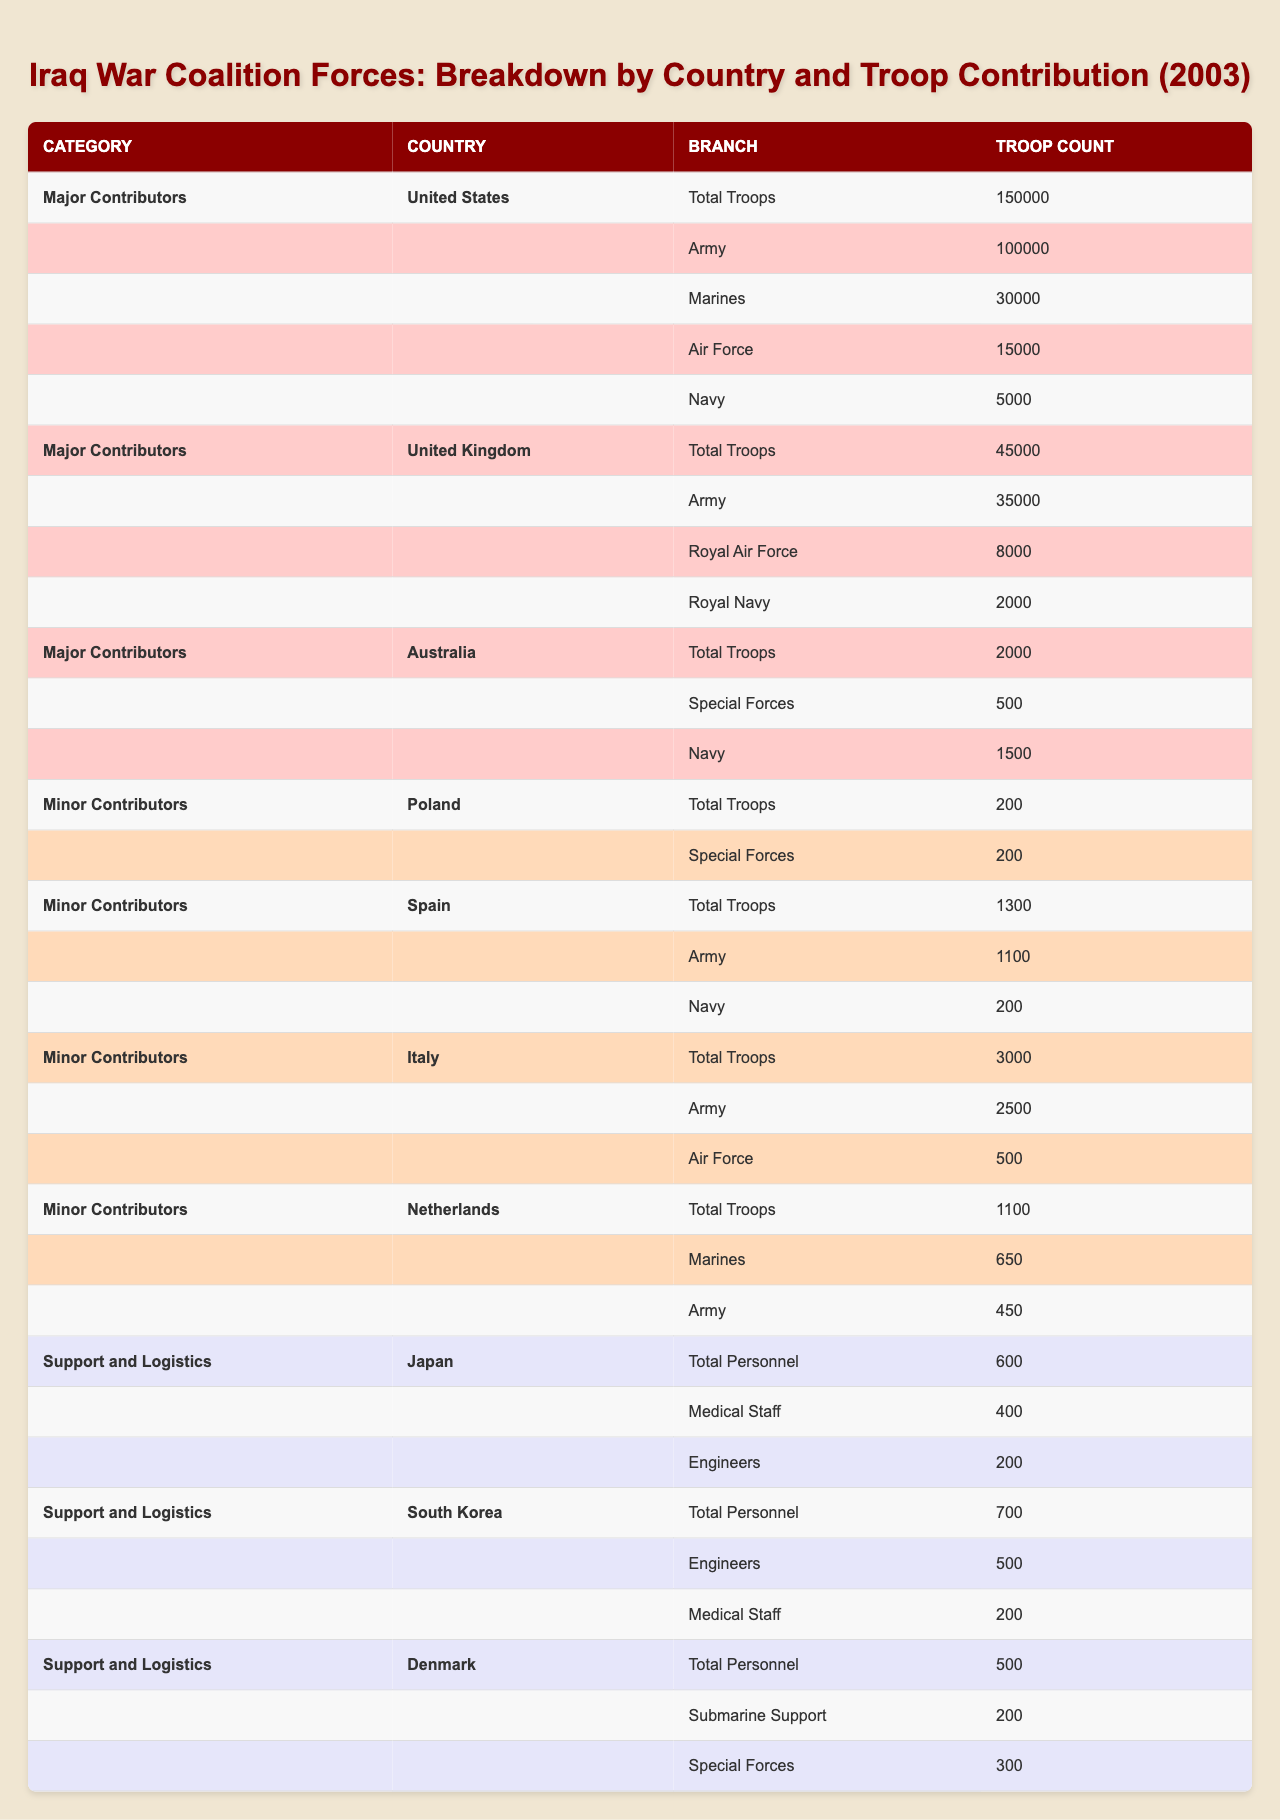What is the total number of troops contributed by the United States? The table shows that the total number of troops contributed by the United States is listed directly under its section, which is 150,000.
Answer: 150,000 How many troops did the United Kingdom contribute in total? From the table, the total number of troops contributed by the United Kingdom is directly stated as 45,000.
Answer: 45,000 Which country contributed the fewest troops in the "Minor Contributors" category? From the "Minor Contributors" section, Poland contributed the least with a total of 200 troops.
Answer: Poland What is the sum of the Army troops provided by Italy and the Netherlands? Italy contributed 2,500 Army troops, and the Netherlands contributed 450 Army troops. Adding these amounts, 2500 + 450 = 2950.
Answer: 2950 Did Japan contribute any Army troops? The table does not list any Army troops contributed by Japan; it only mentions medical staff and engineers. Therefore, the answer is no.
Answer: No How many Total Personnel did South Korea contribute compared to Japan? South Korea contributed 700 Total Personnel, while Japan contributed 600. The difference is 700 - 600 = 100. Thus, South Korea contributed 100 more personnel than Japan.
Answer: 100 more What percentage of the total troops contributed by the United States are Marines? The United States contributed 150,000 troops in total, 30,000 of which were Marines. The percentage is calculated as (30,000 / 150,000) * 100 = 20%.
Answer: 20% What is the combined total of Special Forces from Australia and Denmark? Australia contributed 500 Special Forces, while Denmark contributed 300 Special Forces. The total is 500 + 300 = 800.
Answer: 800 Which country had the highest contribution of Army troops among major contributors? The United States contributed 100,000 Army troops, which is higher than the United Kingdom's 35,000. Therefore, the United States had the highest contribution.
Answer: United States How many more Royal Air Force troops did the United Kingdom contribute compared to the Marines from the Netherlands? The United Kingdom contributed 8,000 Royal Air Force troops, while the Netherlands contributed 650 Marines. The difference is 8000 - 650 = 7350.
Answer: 7350 